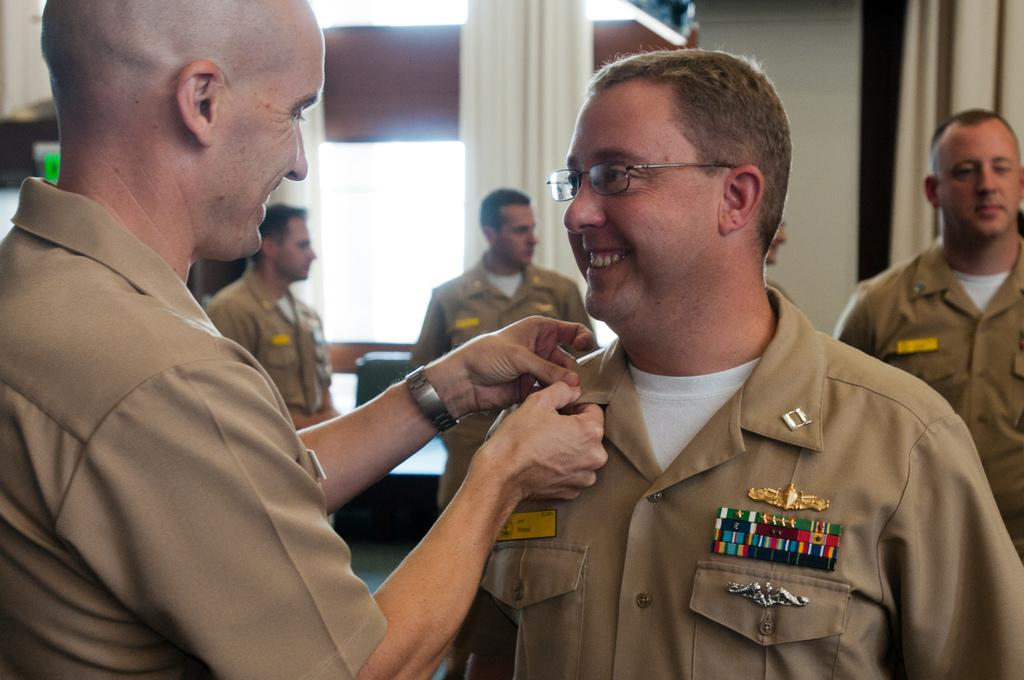What is the man in the foreground doing? The man in the foreground is holding the collar of another man. How many men are standing in the background? There are four men standing in the background. What can be seen in the background besides the men? There is a wall and curtains in the background. What type of cake is being served in the image? There is no cake present in the image. 